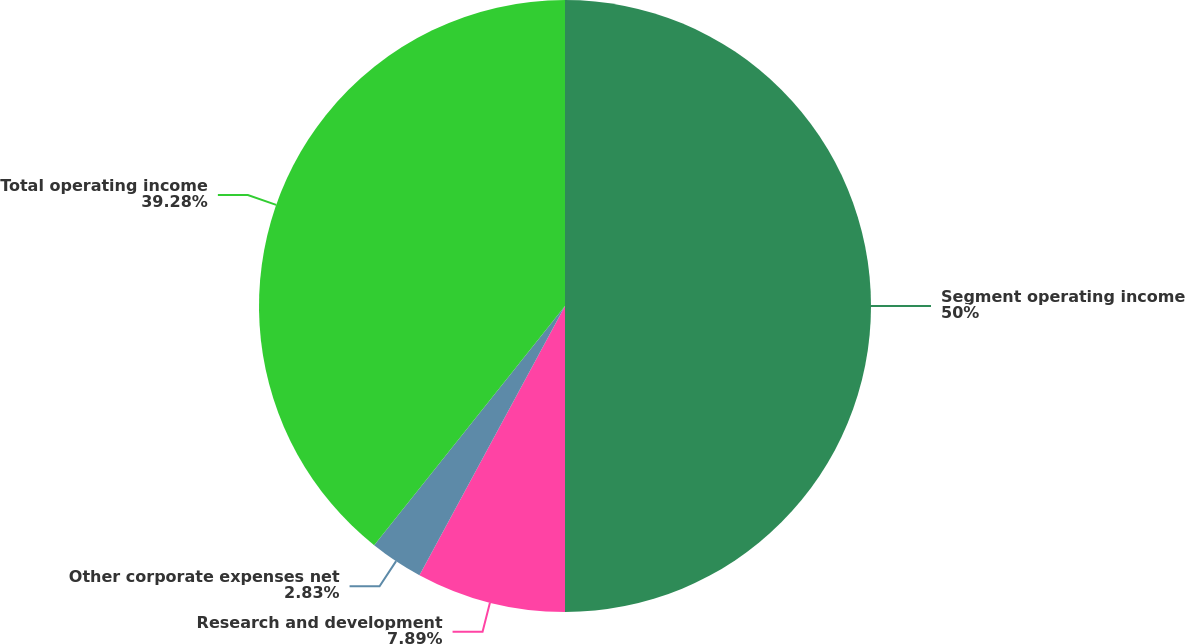Convert chart to OTSL. <chart><loc_0><loc_0><loc_500><loc_500><pie_chart><fcel>Segment operating income<fcel>Research and development<fcel>Other corporate expenses net<fcel>Total operating income<nl><fcel>50.0%<fcel>7.89%<fcel>2.83%<fcel>39.28%<nl></chart> 